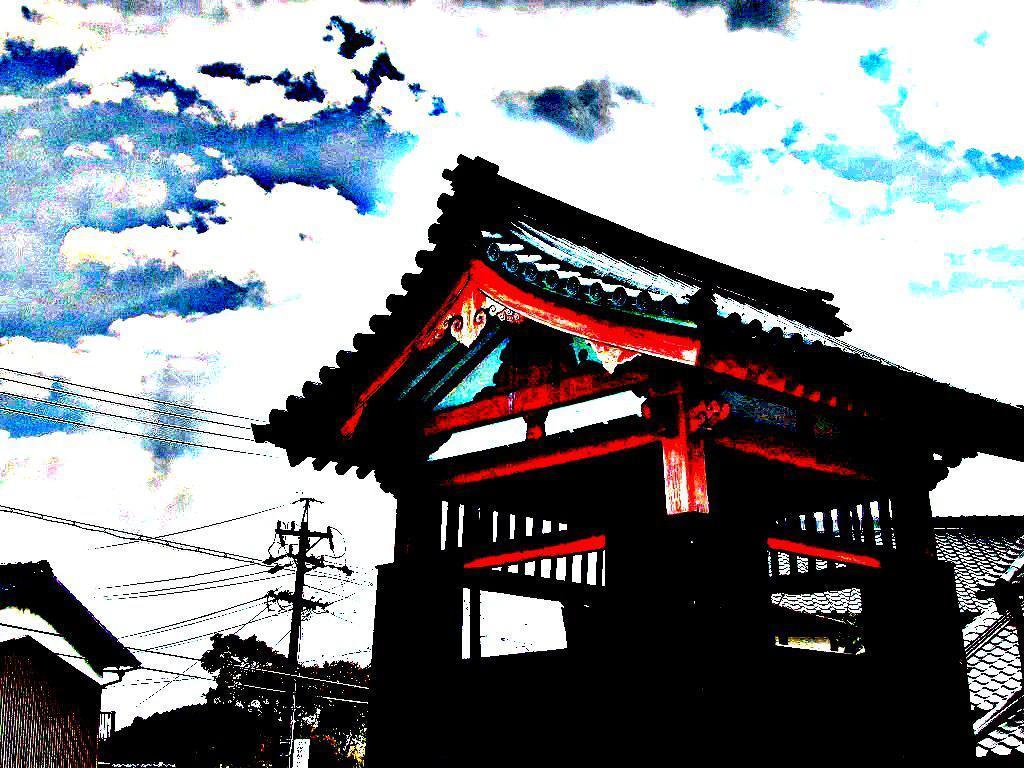Describe this image in one or two sentences. This is an edited image. I can see the buildings, trees, an electric pole and current wires. In the background, there is the sky. 